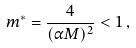<formula> <loc_0><loc_0><loc_500><loc_500>m ^ { * } = \frac { 4 } { ( \alpha M ) ^ { 2 } } < 1 \, ,</formula> 